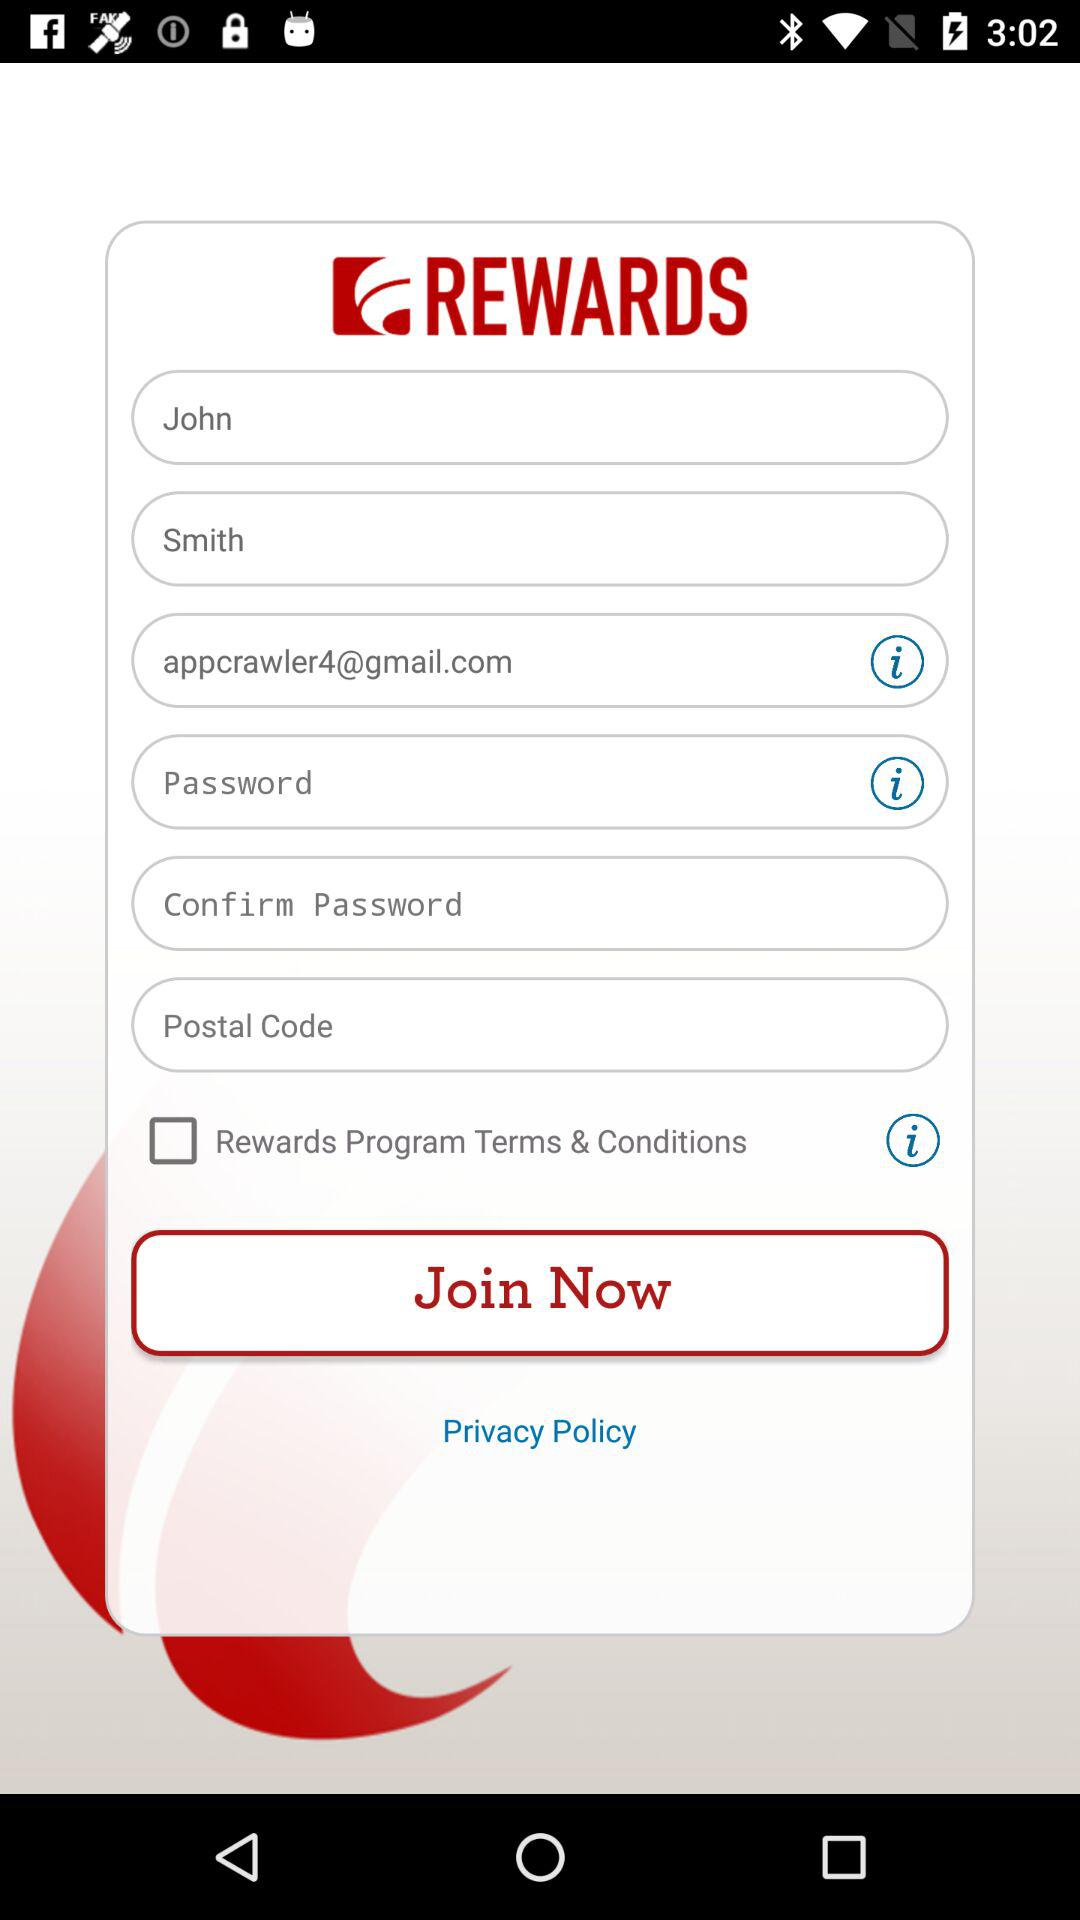What is the name of the user? The name of the user is John Smith. 